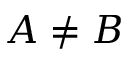<formula> <loc_0><loc_0><loc_500><loc_500>A \neq B</formula> 